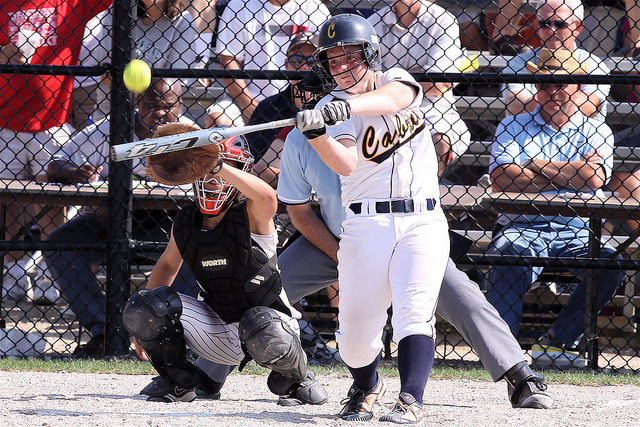What do you think the mood of the players is during this game? The mood of the players appears to be highly focused and intense. The batter is concentrating on hitting the ball, and the catcher is in a vigilant position, ready to react. This suggests a competitive and serious atmosphere during the game. 